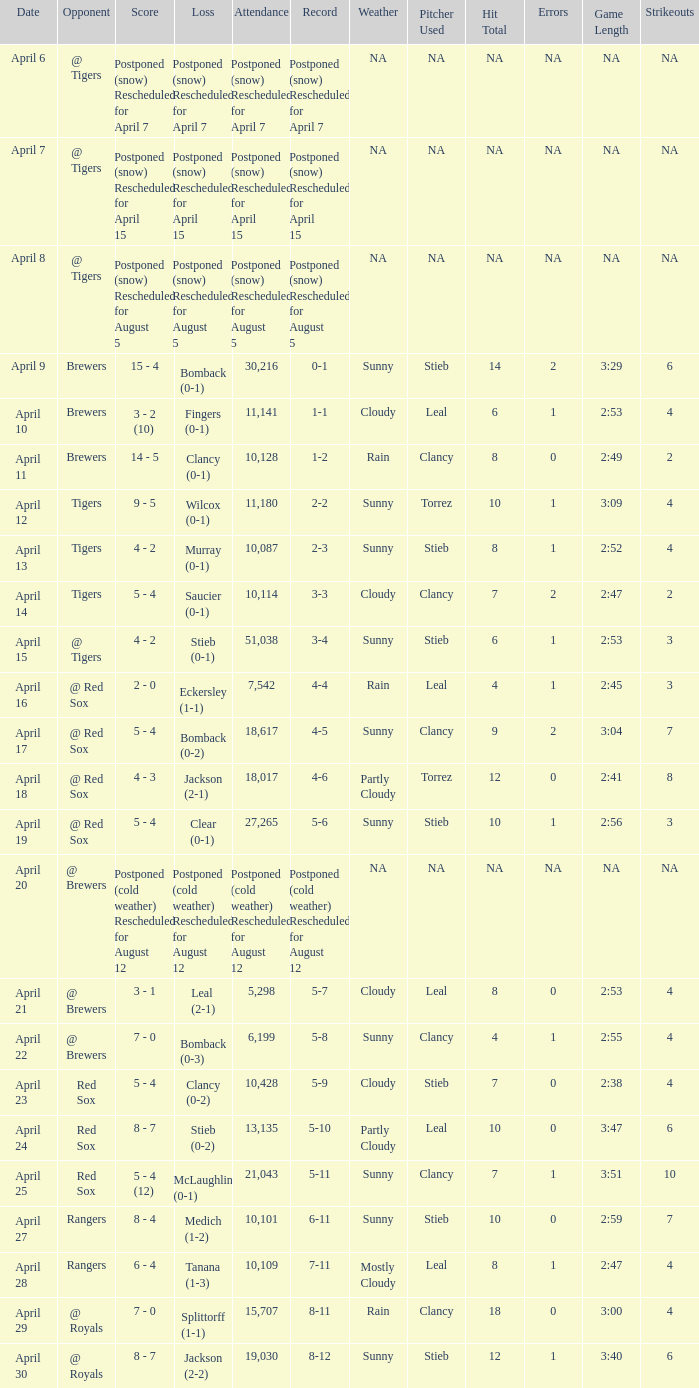What is the record for the game with an attendance of 11,141? 1-1. 